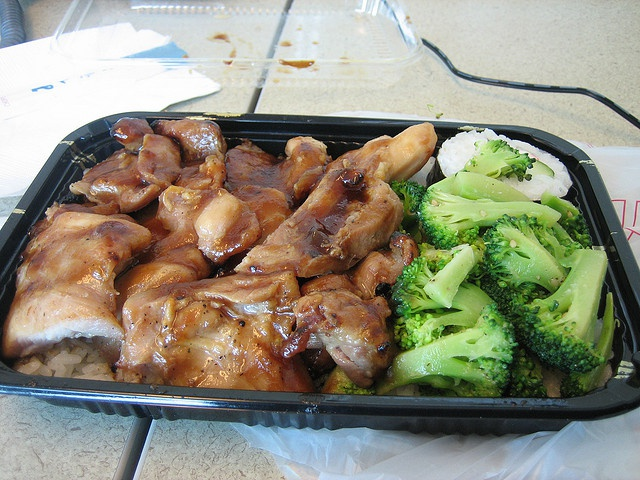Describe the objects in this image and their specific colors. I can see dining table in gray, lightgray, and darkgray tones and broccoli in gray, black, lightgreen, and darkgreen tones in this image. 